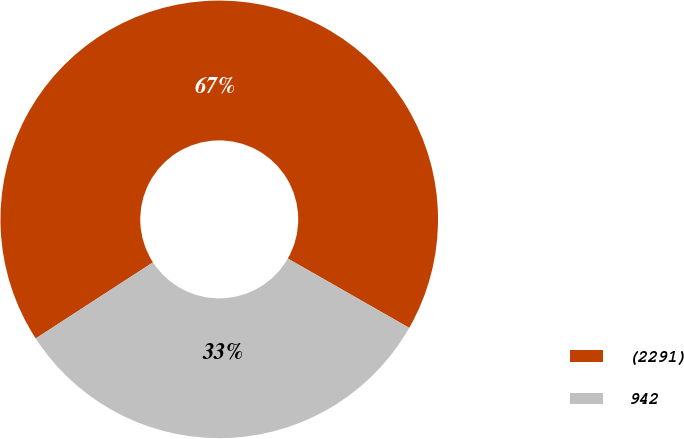Convert chart to OTSL. <chart><loc_0><loc_0><loc_500><loc_500><pie_chart><fcel>(2291)<fcel>942<nl><fcel>67.42%<fcel>32.58%<nl></chart> 